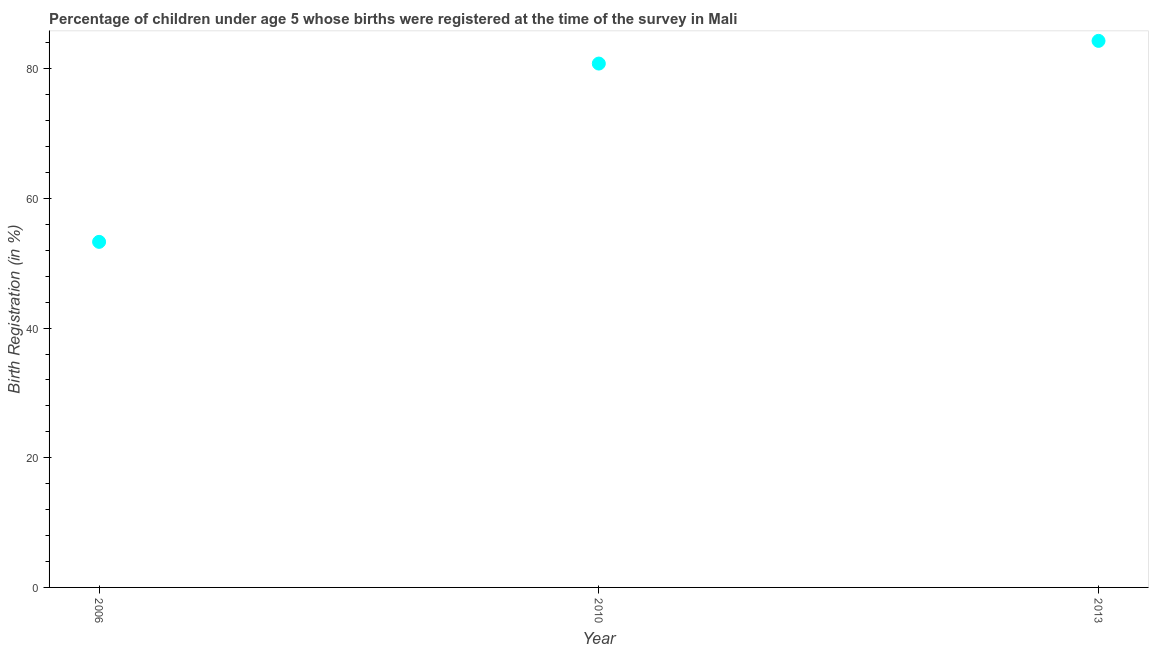What is the birth registration in 2010?
Offer a very short reply. 80.8. Across all years, what is the maximum birth registration?
Offer a very short reply. 84.3. Across all years, what is the minimum birth registration?
Provide a short and direct response. 53.3. What is the sum of the birth registration?
Make the answer very short. 218.4. What is the difference between the birth registration in 2006 and 2013?
Provide a short and direct response. -31. What is the average birth registration per year?
Ensure brevity in your answer.  72.8. What is the median birth registration?
Your response must be concise. 80.8. In how many years, is the birth registration greater than 12 %?
Give a very brief answer. 3. Do a majority of the years between 2013 and 2010 (inclusive) have birth registration greater than 32 %?
Offer a very short reply. No. What is the ratio of the birth registration in 2010 to that in 2013?
Give a very brief answer. 0.96. Is the birth registration in 2010 less than that in 2013?
Ensure brevity in your answer.  Yes. Is the difference between the birth registration in 2006 and 2010 greater than the difference between any two years?
Offer a terse response. No. What is the difference between the highest and the second highest birth registration?
Offer a terse response. 3.5. What is the difference between the highest and the lowest birth registration?
Give a very brief answer. 31. In how many years, is the birth registration greater than the average birth registration taken over all years?
Provide a short and direct response. 2. Does the birth registration monotonically increase over the years?
Make the answer very short. Yes. How many years are there in the graph?
Your response must be concise. 3. What is the difference between two consecutive major ticks on the Y-axis?
Make the answer very short. 20. Does the graph contain any zero values?
Provide a short and direct response. No. Does the graph contain grids?
Offer a very short reply. No. What is the title of the graph?
Your answer should be compact. Percentage of children under age 5 whose births were registered at the time of the survey in Mali. What is the label or title of the X-axis?
Give a very brief answer. Year. What is the label or title of the Y-axis?
Ensure brevity in your answer.  Birth Registration (in %). What is the Birth Registration (in %) in 2006?
Your answer should be compact. 53.3. What is the Birth Registration (in %) in 2010?
Your response must be concise. 80.8. What is the Birth Registration (in %) in 2013?
Provide a succinct answer. 84.3. What is the difference between the Birth Registration (in %) in 2006 and 2010?
Your answer should be very brief. -27.5. What is the difference between the Birth Registration (in %) in 2006 and 2013?
Keep it short and to the point. -31. What is the difference between the Birth Registration (in %) in 2010 and 2013?
Ensure brevity in your answer.  -3.5. What is the ratio of the Birth Registration (in %) in 2006 to that in 2010?
Ensure brevity in your answer.  0.66. What is the ratio of the Birth Registration (in %) in 2006 to that in 2013?
Ensure brevity in your answer.  0.63. What is the ratio of the Birth Registration (in %) in 2010 to that in 2013?
Your response must be concise. 0.96. 